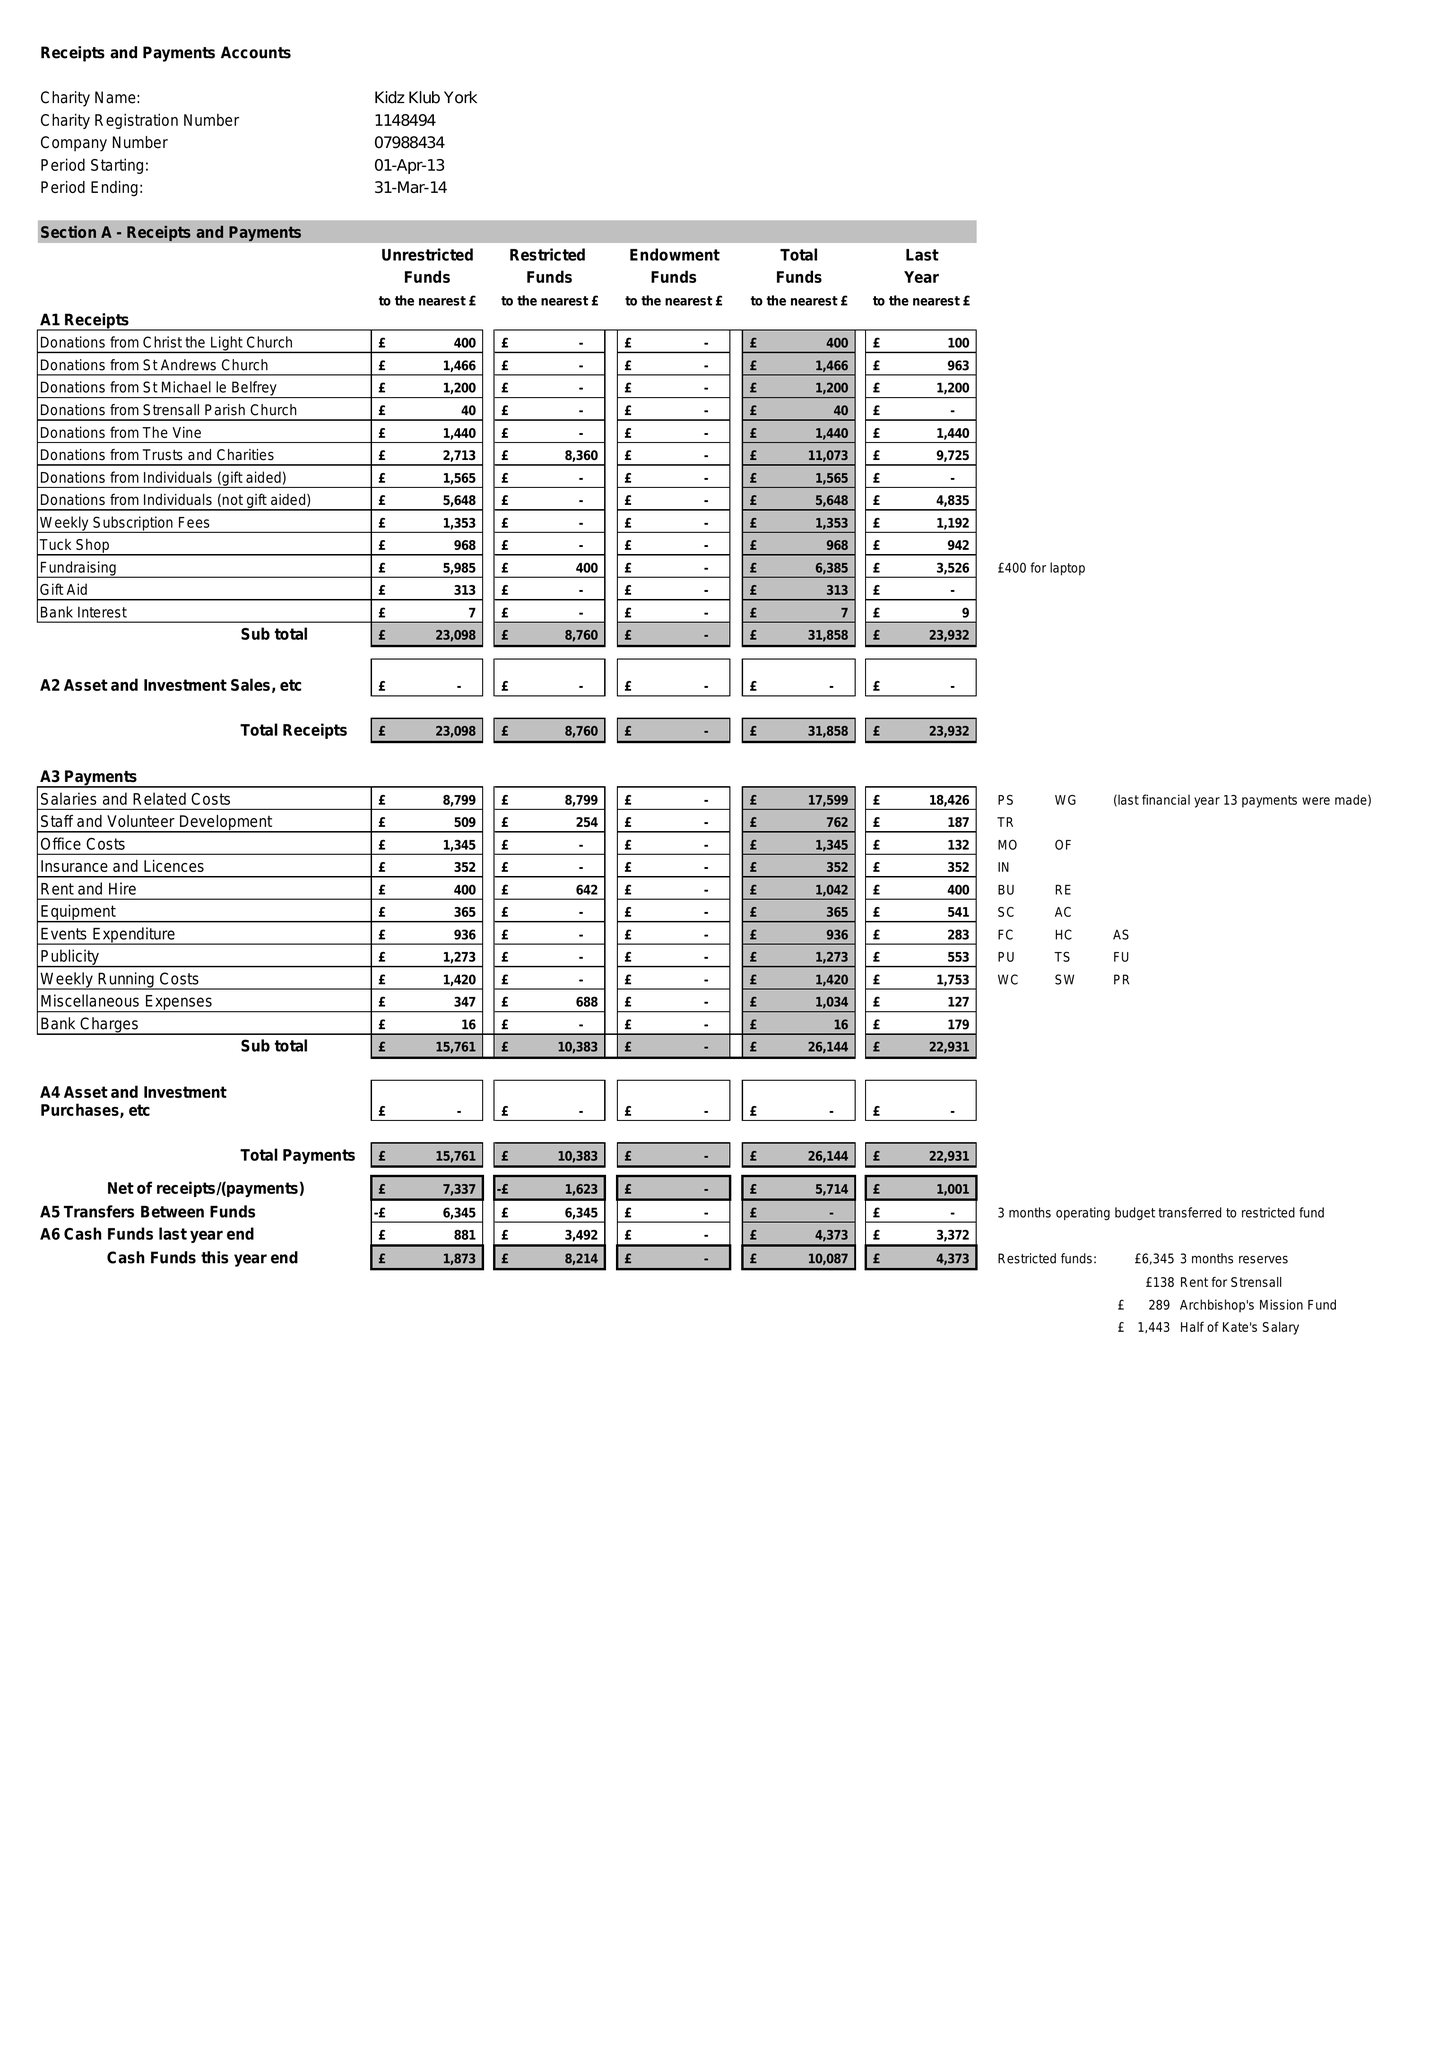What is the value for the spending_annually_in_british_pounds?
Answer the question using a single word or phrase. 26144.00 